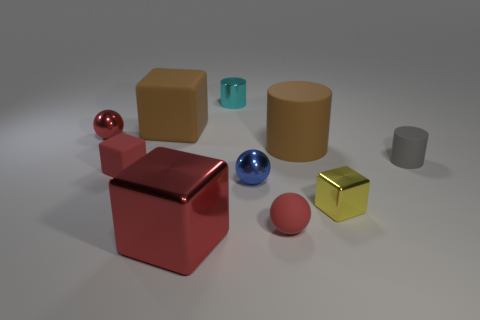How many other objects are there of the same material as the small blue ball?
Keep it short and to the point. 4. There is a red matte cube; is its size the same as the red ball that is in front of the small matte cylinder?
Offer a very short reply. Yes. Is the number of tiny blue metal objects behind the red rubber block greater than the number of small red spheres?
Ensure brevity in your answer.  No. What is the size of the blue thing that is the same material as the cyan cylinder?
Offer a very short reply. Small. Are there any other metallic cylinders of the same color as the tiny shiny cylinder?
Your response must be concise. No. How many things are big green matte objects or large things to the right of the cyan object?
Make the answer very short. 1. Is the number of small yellow blocks greater than the number of red rubber objects?
Provide a succinct answer. No. The matte cube that is the same color as the large cylinder is what size?
Your response must be concise. Large. Is there a blue sphere made of the same material as the tiny gray cylinder?
Keep it short and to the point. No. What is the shape of the tiny metallic object that is both behind the yellow metallic thing and to the right of the tiny cyan shiny thing?
Offer a terse response. Sphere. 